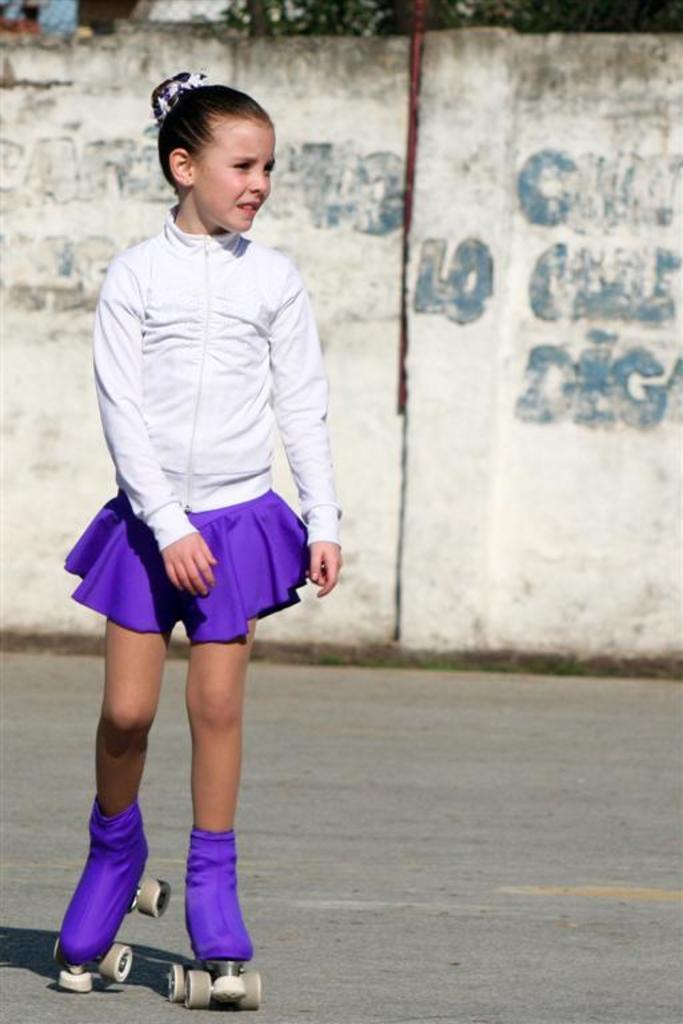How would you summarize this image in a sentence or two? This picture shows a girl skating with the help of skate shoes to her legs and we see a wall and we see text painted on it. 